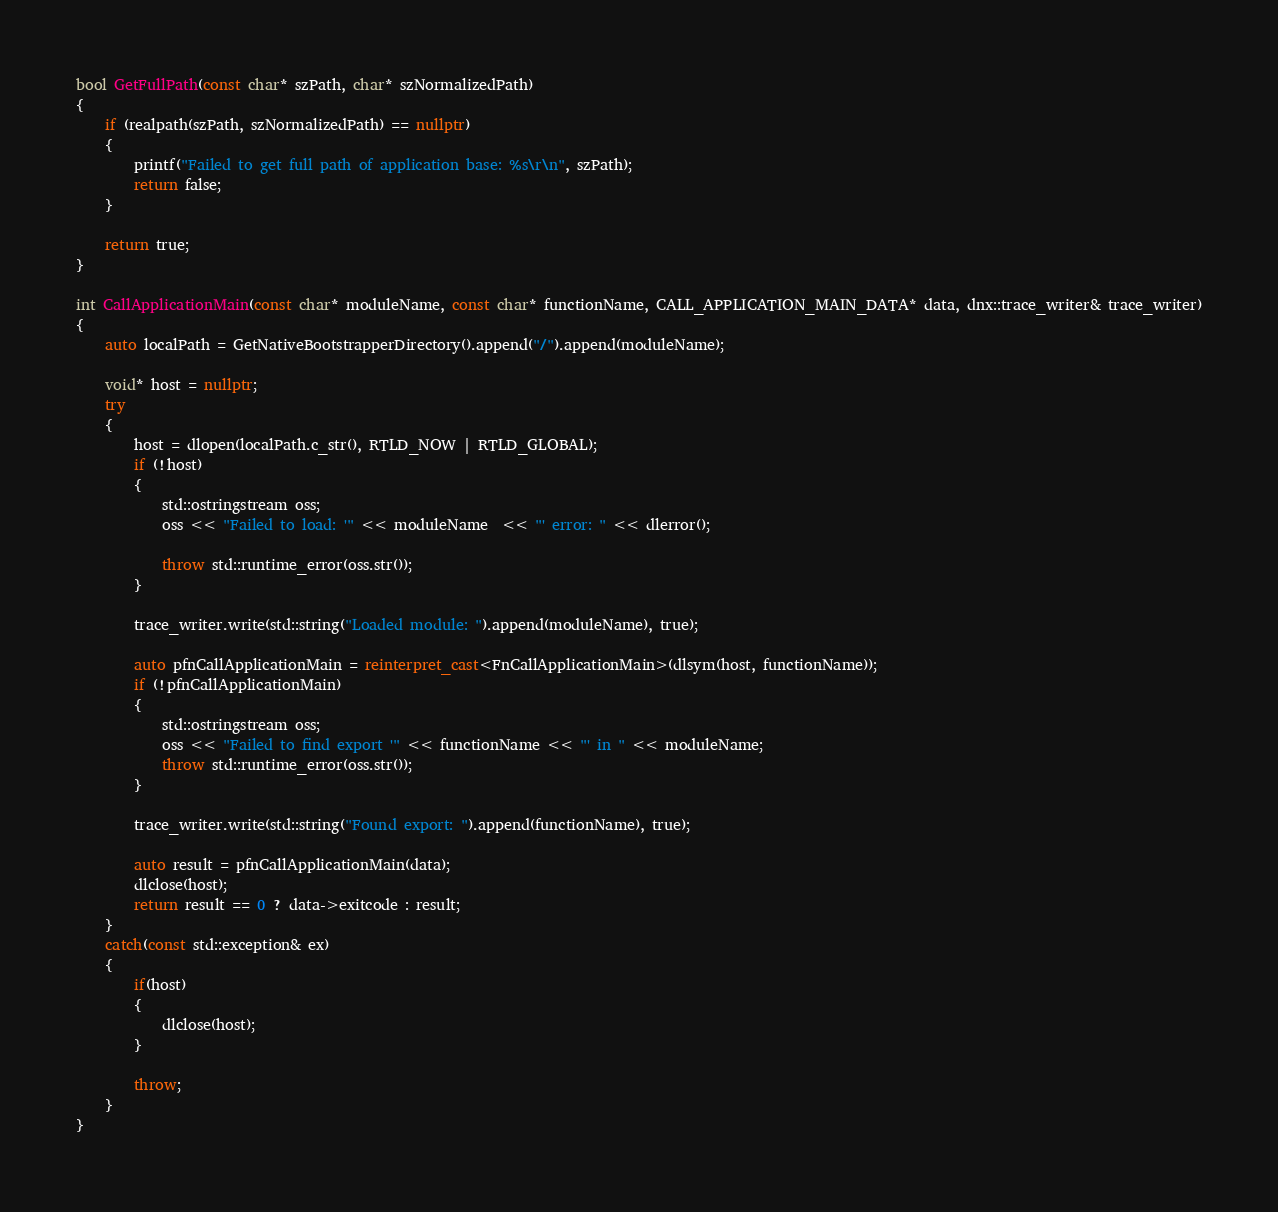Convert code to text. <code><loc_0><loc_0><loc_500><loc_500><_C++_>bool GetFullPath(const char* szPath, char* szNormalizedPath)
{
    if (realpath(szPath, szNormalizedPath) == nullptr)
    {
        printf("Failed to get full path of application base: %s\r\n", szPath);
        return false;
    }

    return true;
}

int CallApplicationMain(const char* moduleName, const char* functionName, CALL_APPLICATION_MAIN_DATA* data, dnx::trace_writer& trace_writer)
{
    auto localPath = GetNativeBootstrapperDirectory().append("/").append(moduleName);

    void* host = nullptr;
    try
    {
        host = dlopen(localPath.c_str(), RTLD_NOW | RTLD_GLOBAL);
        if (!host)
        {
            std::ostringstream oss;
            oss << "Failed to load: '" << moduleName  << "' error: " << dlerror();

            throw std::runtime_error(oss.str());
        }

        trace_writer.write(std::string("Loaded module: ").append(moduleName), true);

        auto pfnCallApplicationMain = reinterpret_cast<FnCallApplicationMain>(dlsym(host, functionName));
        if (!pfnCallApplicationMain)
        {
            std::ostringstream oss;
            oss << "Failed to find export '" << functionName << "' in " << moduleName;
            throw std::runtime_error(oss.str());
        }

        trace_writer.write(std::string("Found export: ").append(functionName), true);

        auto result = pfnCallApplicationMain(data);
        dlclose(host);
        return result == 0 ? data->exitcode : result;
    }
    catch(const std::exception& ex)
    {
        if(host)
        {
            dlclose(host);
        }

        throw;
    }
}</code> 